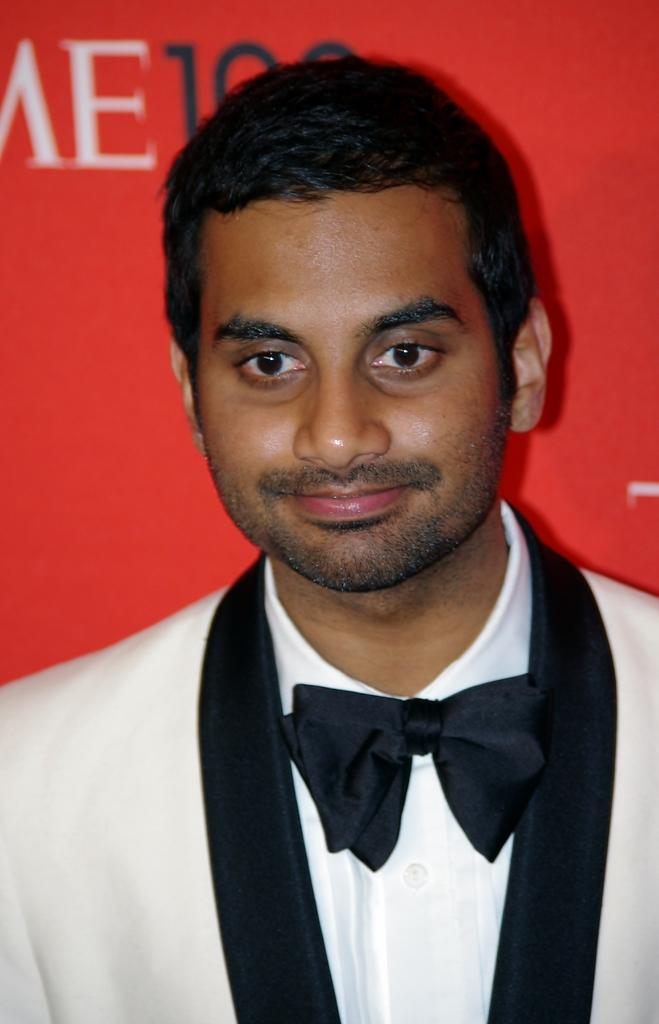Who or what is the main subject in the image? There is a person in the image. What color is the background of the image? The background of the image is red. What else can be seen on the red background? There is text visible on the red background. What type of hair can be seen on the person's tongue in the image? There is no hair or tongue visible in the image; it only features a person with a red background and text. 